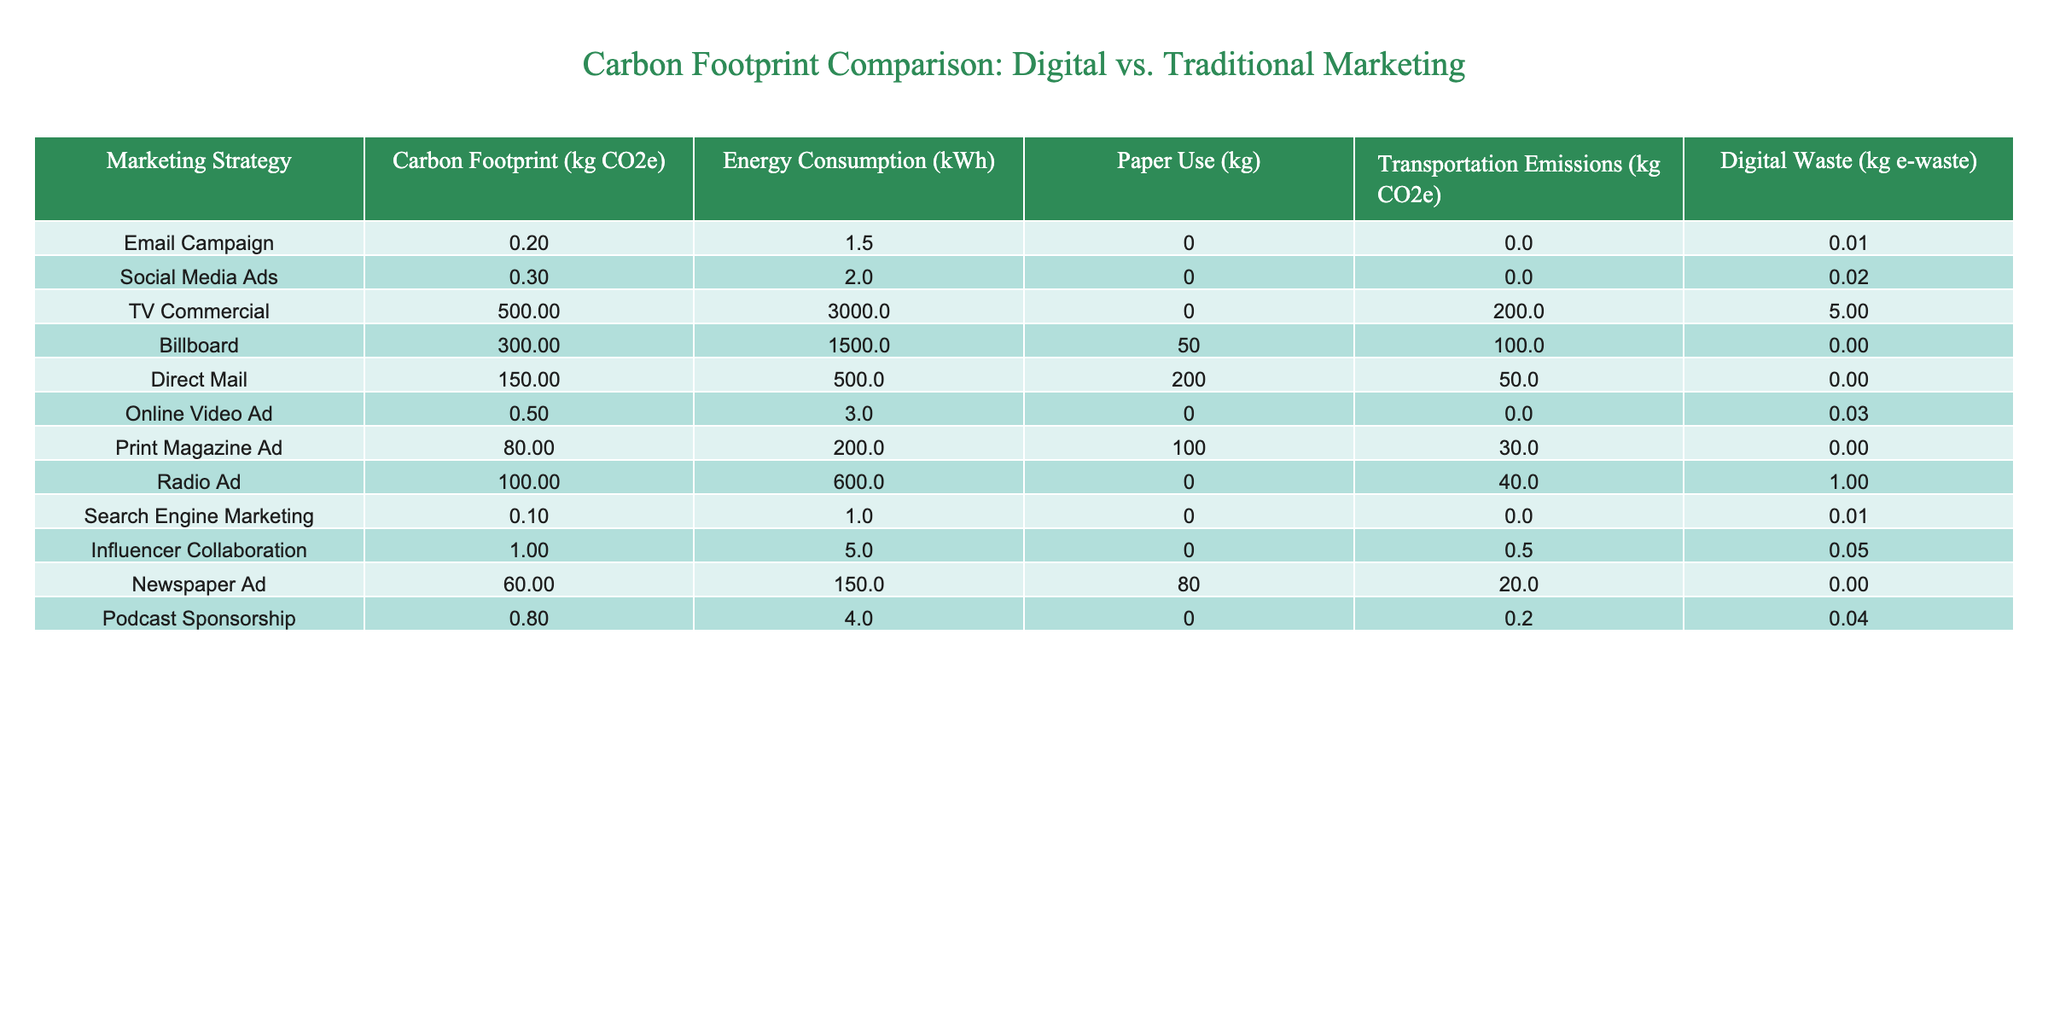What is the carbon footprint of a TV commercial? The table shows that the carbon footprint for a TV commercial is 500 kg CO2e.
Answer: 500 kg CO2e Which marketing strategy has the highest carbon footprint? The table indicates that the TV commercial has the highest carbon footprint at 500 kg CO2e, higher than any other strategy listed.
Answer: TV Commercial How much energy does a Social Media Ad consume? According to the table, a Social Media Ad consumes 2.0 kWh of energy.
Answer: 2.0 kWh What is the total carbon footprint of all traditional marketing strategies? The sum of the carbon footprints for traditional marketing strategies (TV Commercial, Billboard, Direct Mail, Print Magazine Ad, Radio Ad, Newspaper Ad) is calculated as 500 + 300 + 150 + 80 + 100 + 60 = 1190 kg CO2e.
Answer: 1190 kg CO2e Do Email campaigns produce any paper use? The table shows that Email campaigns have a paper use of 0 kg, indicating they do not use paper.
Answer: No Which strategy produces the least digital waste? The table indicates that the Direct Mail campaign has 0 kg of digital waste, making it the strategy with the least digital waste.
Answer: Direct Mail What is the average carbon footprint of digital marketing campaigns? The carbon footprints for digital marketing strategies are: Email Campaign (0.2), Social Media Ads (0.3), Online Video Ad (0.5), Search Engine Marketing (0.1), Influencer Collaboration (1.0), Podcast Sponsorship (0.8). Their sum is 0.2 + 0.3 + 0.5 + 0.1 + 1.0 + 0.8 = 2.9 kg CO2e. The average is 2.9 kg CO2e / 6 ≈ 0.48 kg CO2e.
Answer: Approximately 0.48 kg CO2e What is the difference in carbon footprint between a Podcast Sponsorship and a Print Magazine Ad? A Podcast Sponsorship has a carbon footprint of 0.8 kg CO2e and a Print Magazine Ad has 80 kg CO2e. The difference is 80 - 0.8 = 79.2 kg CO2e.
Answer: 79.2 kg CO2e Is it true that all marketing strategies listed have a carbon footprint greater than zero? By reviewing the table, we see that all strategies have positive carbon footprints, confirming that the statement is true.
Answer: Yes Which marketing strategy has the highest transportation emissions? The table shows that the TV commercial has the highest transportation emissions at 200 kg CO2e.
Answer: TV Commercial How much paper is used in total across all marketing strategies? The total paper use is calculated by summing the paper usage: 0 + 0 + 0 + 50 + 200 + 100 + 0 + 0 + 80 + 0 = 430 kg.
Answer: 430 kg 